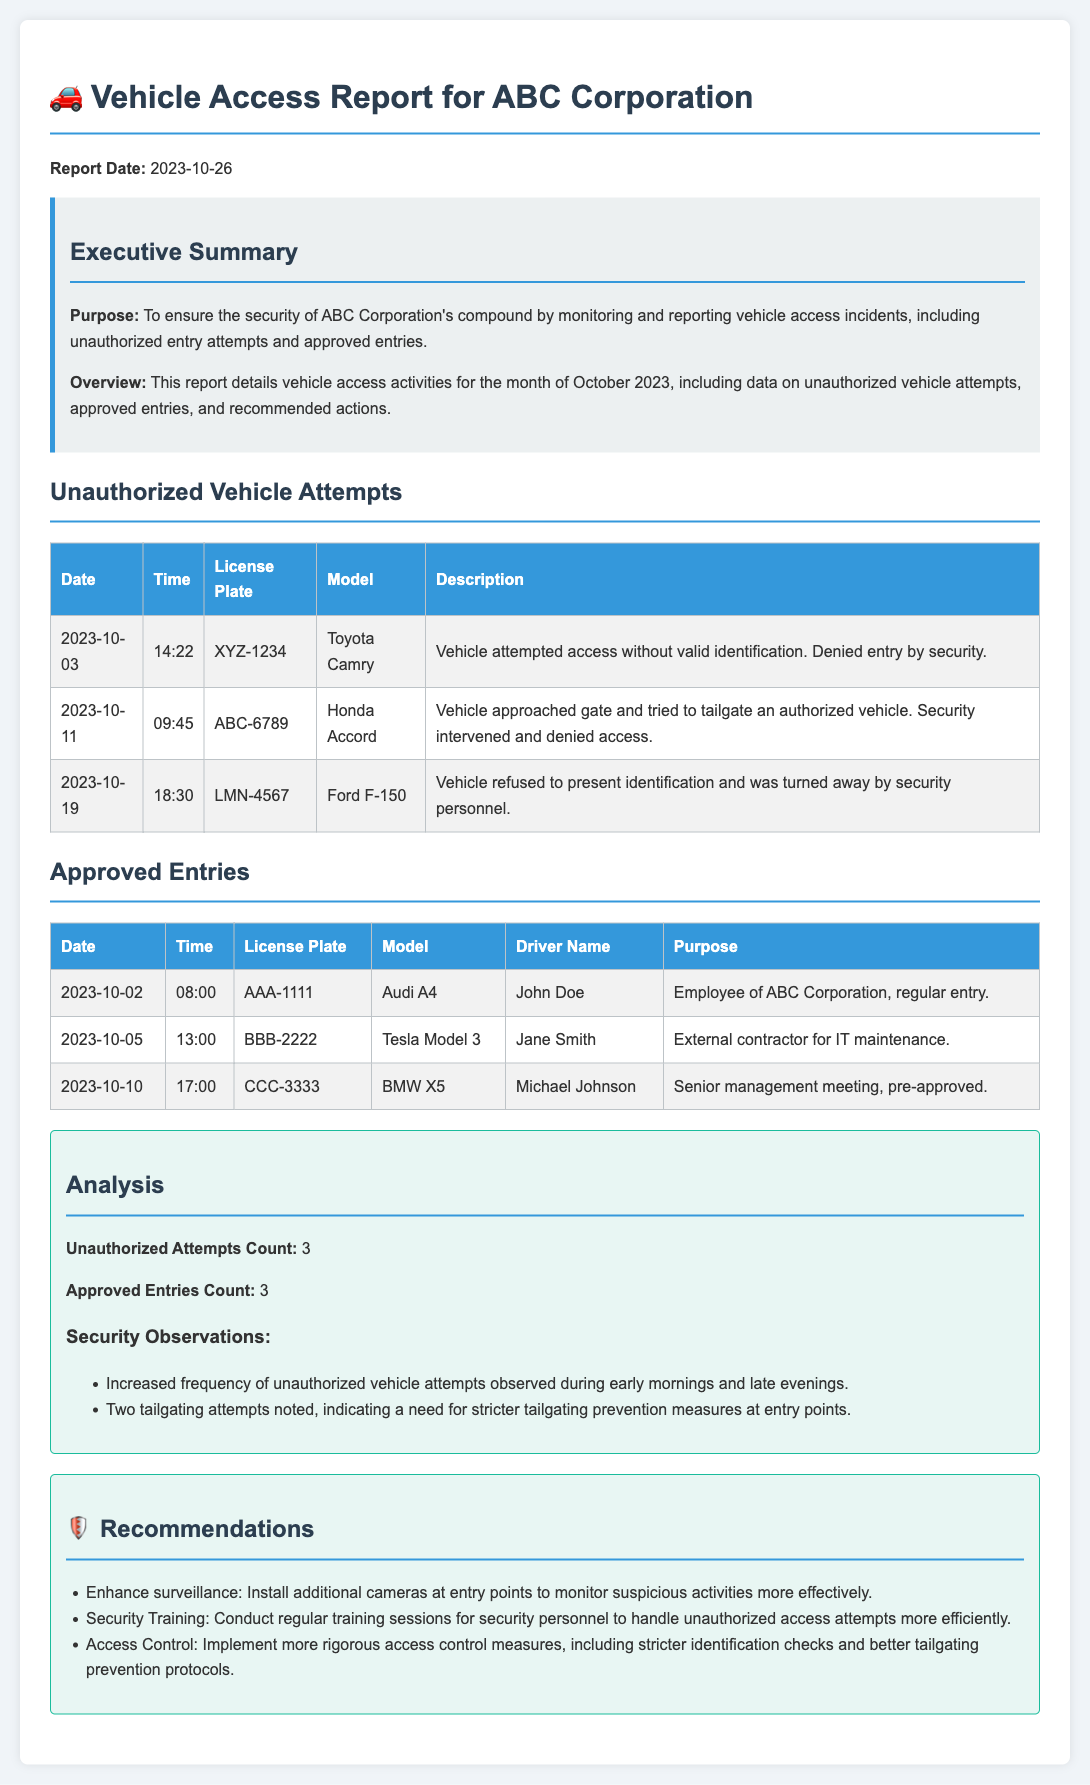What is the report date? The report date is mentioned in the document header.
Answer: 2023-10-26 How many unauthorized vehicle attempts were recorded? The number of unauthorized vehicle attempts is specified in the analysis section of the report.
Answer: 3 What vehicle model was involved in the tailgating attempt on October 11? The model of the vehicle involved in the tailgating attempt is noted in the unauthorized vehicle attempts table.
Answer: Honda Accord Who was driving the Audi A4 that entered on October 2? The driver's name for the Audi A4 is provided in the approved entries section.
Answer: John Doe What is one recommended action to enhance security? The recommendations section lists specific actions to improve security measures.
Answer: Install additional cameras at entry points What time did the unauthorized vehicle attempt on October 19 occur? The time of the unauthorized vehicle attempt is found in the corresponding row of the table.
Answer: 18:30 What company does this report pertain to? The purpose of the report clarifies which corporation's security is being analyzed.
Answer: ABC Corporation How many approved entries were recorded? The number of approved entries is also mentioned in the analysis section of the report.
Answer: 3 